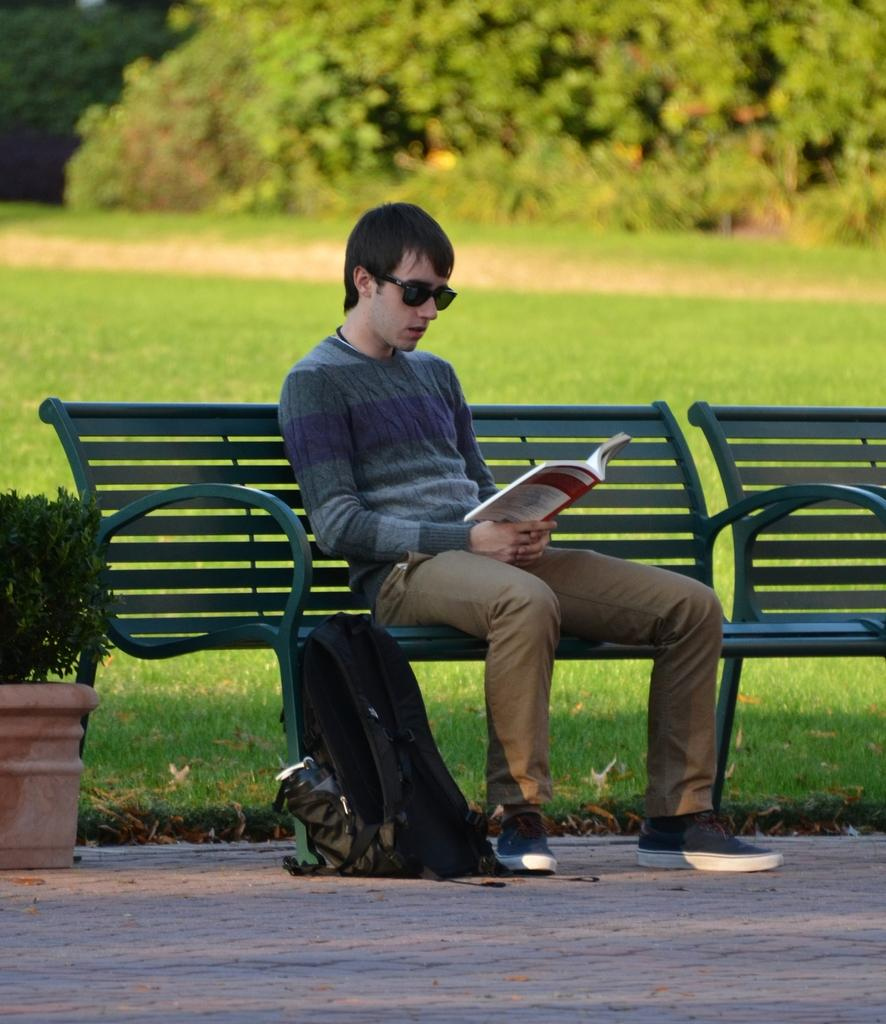What is the person sitting on in the image? There is a person sitting on a green bench in the image. What is the person doing while sitting on the bench? The person is reading a book. What accessory is the person wearing? The person is wearing goggles. What is located to the person's left? There is a black bag and a plant to the person's left. What type of vegetation can be seen in the background of the image? There is grass and trees visible at the back. What language is the person speaking while reading the book in the image? There is no indication in the image that the person is speaking while reading the book, and therefore no language can be determined. 